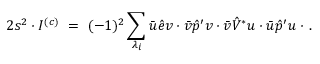<formula> <loc_0><loc_0><loc_500><loc_500>2 s ^ { 2 } \cdot I ^ { ( c ) } \ = \ ( - 1 ) ^ { 2 } \sum _ { \lambda _ { i } } \bar { u } \hat { e } v \cdot \bar { v } \hat { p } ^ { \prime } v \cdot \bar { v } \hat { V } ^ { * } u \cdot \bar { u } \hat { p } ^ { \prime } u \cdot \, .</formula> 